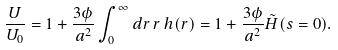<formula> <loc_0><loc_0><loc_500><loc_500>\frac { U } { U _ { 0 } } = 1 + \frac { 3 \phi } { a ^ { 2 } } \int _ { 0 } ^ { \infty } d r \, r \, h ( r ) = 1 + \frac { 3 \phi } { a ^ { 2 } } \tilde { H } ( s = 0 ) .</formula> 